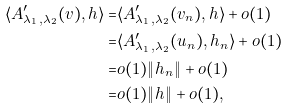<formula> <loc_0><loc_0><loc_500><loc_500>\langle A ^ { \prime } _ { \lambda _ { 1 } , \lambda _ { 2 } } ( v ) , h \rangle = & \langle A ^ { \prime } _ { \lambda _ { 1 } , \lambda _ { 2 } } ( v _ { n } ) , h \rangle + o ( 1 ) \\ = & \langle A ^ { \prime } _ { \lambda _ { 1 } , \lambda _ { 2 } } ( u _ { n } ) , h _ { n } \rangle + o ( 1 ) \\ = & o ( 1 ) \| h _ { n } \| + o ( 1 ) \\ = & o ( 1 ) \| h \| + o ( 1 ) ,</formula> 